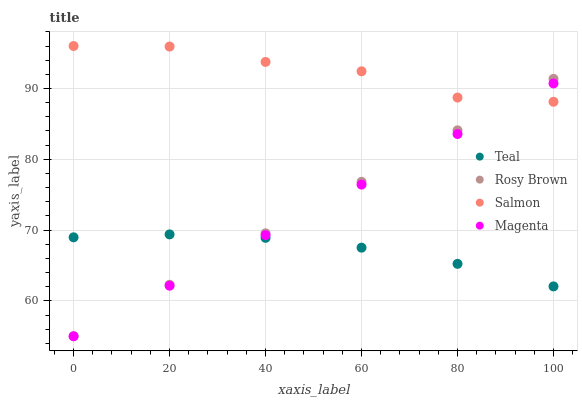Does Teal have the minimum area under the curve?
Answer yes or no. Yes. Does Salmon have the maximum area under the curve?
Answer yes or no. Yes. Does Rosy Brown have the minimum area under the curve?
Answer yes or no. No. Does Rosy Brown have the maximum area under the curve?
Answer yes or no. No. Is Magenta the smoothest?
Answer yes or no. Yes. Is Salmon the roughest?
Answer yes or no. Yes. Is Rosy Brown the smoothest?
Answer yes or no. No. Is Rosy Brown the roughest?
Answer yes or no. No. Does Magenta have the lowest value?
Answer yes or no. Yes. Does Salmon have the lowest value?
Answer yes or no. No. Does Salmon have the highest value?
Answer yes or no. Yes. Does Rosy Brown have the highest value?
Answer yes or no. No. Is Teal less than Salmon?
Answer yes or no. Yes. Is Salmon greater than Teal?
Answer yes or no. Yes. Does Salmon intersect Rosy Brown?
Answer yes or no. Yes. Is Salmon less than Rosy Brown?
Answer yes or no. No. Is Salmon greater than Rosy Brown?
Answer yes or no. No. Does Teal intersect Salmon?
Answer yes or no. No. 